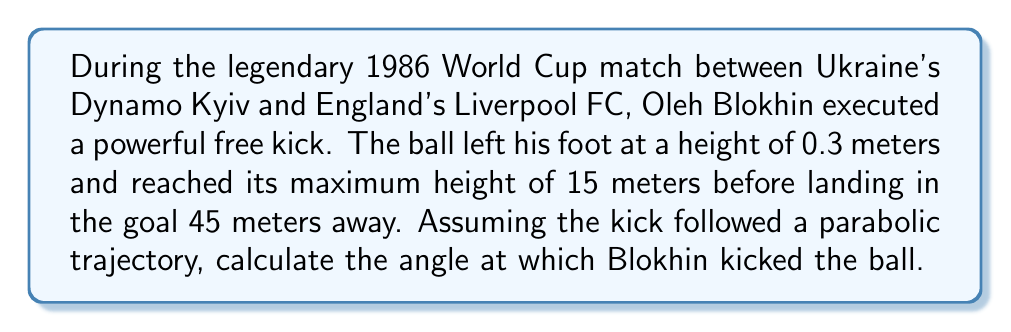Solve this math problem. Let's approach this step-by-step using projectile motion equations:

1) First, let's define our variables:
   $h_0 = 0.3$ m (initial height)
   $h_{max} = 15$ m (maximum height)
   $R = 45$ m (horizontal distance)
   $\theta$ = angle of kick (what we're solving for)
   $g = 9.8$ m/s² (acceleration due to gravity)

2) The time to reach the maximum height is half the total flight time. Let's call the total flight time $T$. So, time to max height = $T/2$.

3) Using the equation for vertical displacement:
   $$h_{max} = h_0 + v_0\sin\theta \cdot \frac{T}{2} - \frac{1}{2}g\left(\frac{T}{2}\right)^2$$

4) We can also use the horizontal displacement equation:
   $$R = v_0\cos\theta \cdot T$$

5) From step 3, we can derive:
   $$v_0\sin\theta = \sqrt{2g(h_{max} - h_0)}$$

6) From step 4:
   $$v_0\cos\theta = \frac{R}{T}$$

7) Dividing step 5 by step 6:
   $$\tan\theta = \frac{\sqrt{2g(h_{max} - h_0)}}{\frac{R}{T}}$$

8) We can eliminate $T$ by using the equation $T = \frac{2R}{v_0\cos\theta}$:
   $$\tan\theta = \frac{2R\sqrt{2g(h_{max} - h_0)}}{R^2g}$$

9) Simplifying:
   $$\tan\theta = \frac{2\sqrt{2g(h_{max} - h_0)}}{Rg}$$

10) Plugging in our values:
    $$\tan\theta = \frac{2\sqrt{2 \cdot 9.8 \cdot (15 - 0.3)}}{45 \cdot 9.8} \approx 0.7638$$

11) Taking the inverse tangent:
    $$\theta = \tan^{-1}(0.7638) \approx 37.37°$$
Answer: $37.37°$ 